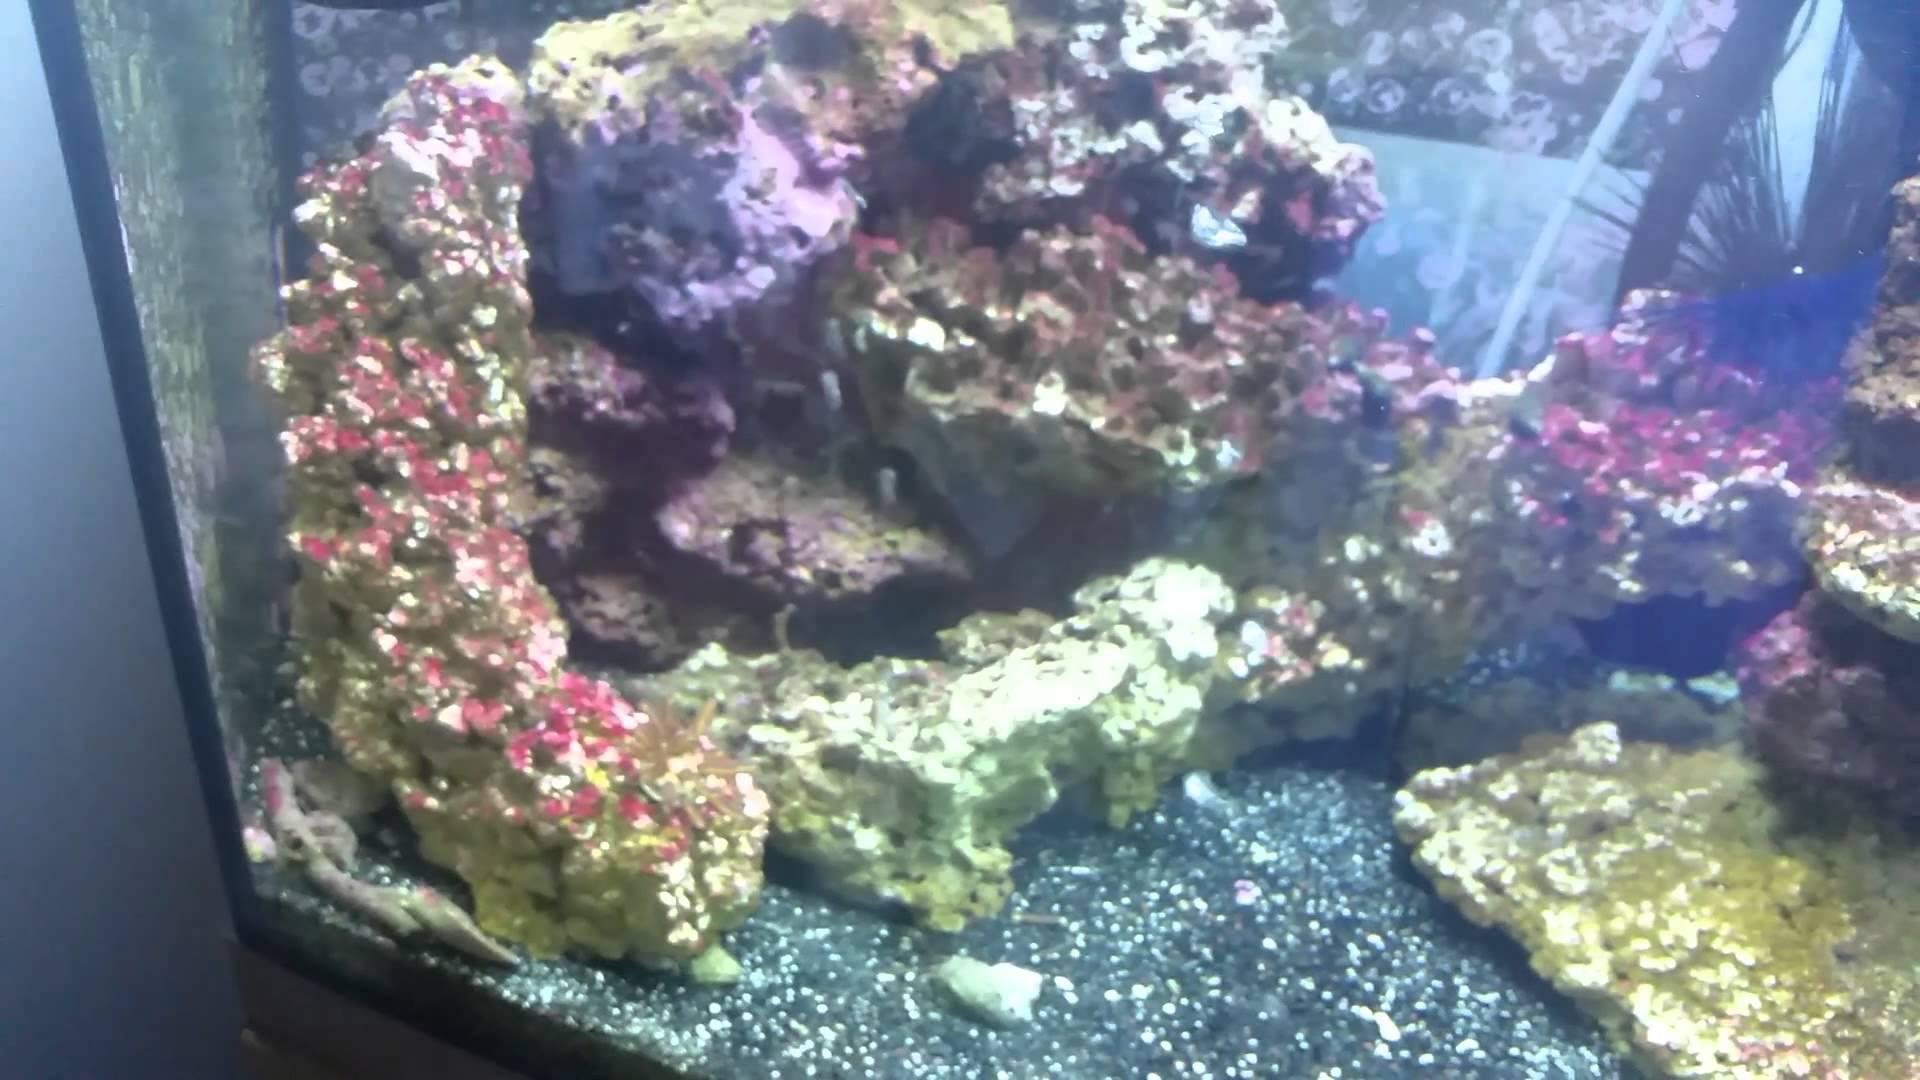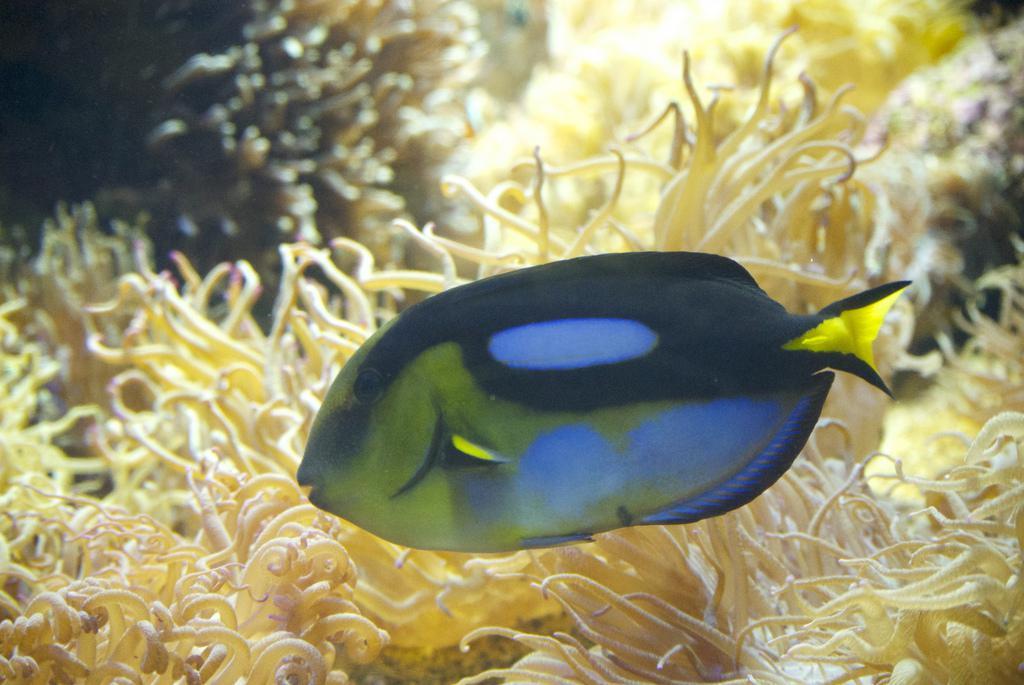The first image is the image on the left, the second image is the image on the right. For the images shown, is this caption "In the image on the right, sea anemones rest in a container with holes in it." true? Answer yes or no. No. The first image is the image on the left, the second image is the image on the right. Considering the images on both sides, is "Atleast one image shows anemone growing on a grid surface, and at least one image features orange-tentacled anemone with pink stalks." valid? Answer yes or no. No. 